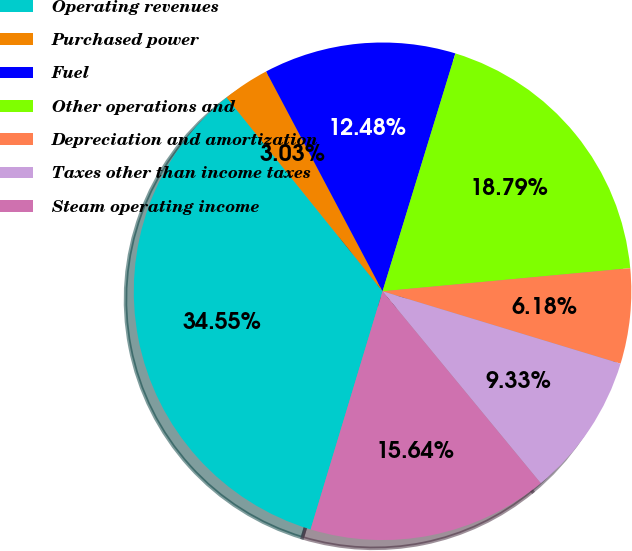Convert chart. <chart><loc_0><loc_0><loc_500><loc_500><pie_chart><fcel>Operating revenues<fcel>Purchased power<fcel>Fuel<fcel>Other operations and<fcel>Depreciation and amortization<fcel>Taxes other than income taxes<fcel>Steam operating income<nl><fcel>34.55%<fcel>3.03%<fcel>12.48%<fcel>18.79%<fcel>6.18%<fcel>9.33%<fcel>15.64%<nl></chart> 